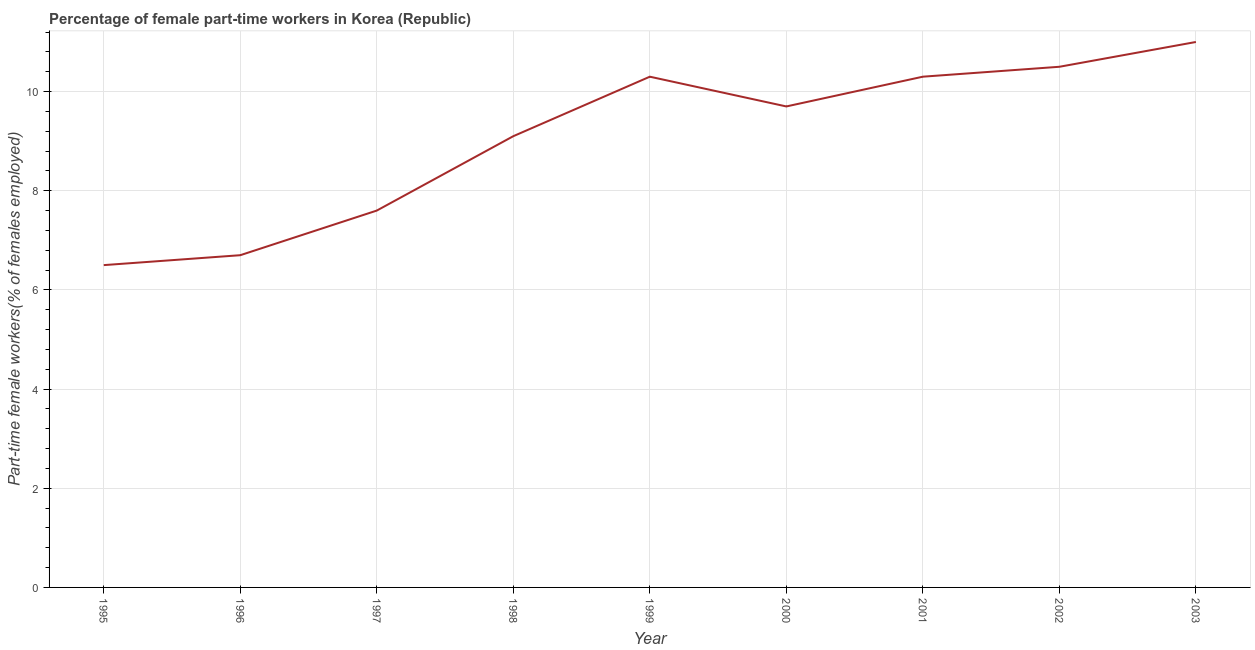What is the percentage of part-time female workers in 2003?
Make the answer very short. 11. In which year was the percentage of part-time female workers maximum?
Give a very brief answer. 2003. In which year was the percentage of part-time female workers minimum?
Keep it short and to the point. 1995. What is the sum of the percentage of part-time female workers?
Provide a succinct answer. 81.7. What is the difference between the percentage of part-time female workers in 1996 and 2001?
Provide a short and direct response. -3.6. What is the average percentage of part-time female workers per year?
Make the answer very short. 9.08. What is the median percentage of part-time female workers?
Your response must be concise. 9.7. Do a majority of the years between 1997 and 2002 (inclusive) have percentage of part-time female workers greater than 6.8 %?
Keep it short and to the point. Yes. What is the ratio of the percentage of part-time female workers in 1996 to that in 1998?
Provide a succinct answer. 0.74. Is the difference between the percentage of part-time female workers in 1998 and 2000 greater than the difference between any two years?
Make the answer very short. No. What is the difference between the highest and the lowest percentage of part-time female workers?
Your answer should be compact. 4.5. How many lines are there?
Provide a succinct answer. 1. What is the difference between two consecutive major ticks on the Y-axis?
Give a very brief answer. 2. What is the title of the graph?
Offer a terse response. Percentage of female part-time workers in Korea (Republic). What is the label or title of the Y-axis?
Offer a terse response. Part-time female workers(% of females employed). What is the Part-time female workers(% of females employed) in 1996?
Make the answer very short. 6.7. What is the Part-time female workers(% of females employed) in 1997?
Ensure brevity in your answer.  7.6. What is the Part-time female workers(% of females employed) of 1998?
Keep it short and to the point. 9.1. What is the Part-time female workers(% of females employed) in 1999?
Offer a very short reply. 10.3. What is the Part-time female workers(% of females employed) in 2000?
Keep it short and to the point. 9.7. What is the Part-time female workers(% of females employed) in 2001?
Give a very brief answer. 10.3. What is the Part-time female workers(% of females employed) of 2002?
Make the answer very short. 10.5. What is the difference between the Part-time female workers(% of females employed) in 1995 and 1997?
Your response must be concise. -1.1. What is the difference between the Part-time female workers(% of females employed) in 1995 and 1999?
Provide a succinct answer. -3.8. What is the difference between the Part-time female workers(% of females employed) in 1995 and 2000?
Provide a succinct answer. -3.2. What is the difference between the Part-time female workers(% of females employed) in 1995 and 2001?
Ensure brevity in your answer.  -3.8. What is the difference between the Part-time female workers(% of females employed) in 1995 and 2002?
Keep it short and to the point. -4. What is the difference between the Part-time female workers(% of females employed) in 1995 and 2003?
Your response must be concise. -4.5. What is the difference between the Part-time female workers(% of females employed) in 1996 and 1999?
Provide a succinct answer. -3.6. What is the difference between the Part-time female workers(% of females employed) in 1997 and 1998?
Your answer should be compact. -1.5. What is the difference between the Part-time female workers(% of females employed) in 1997 and 2000?
Offer a terse response. -2.1. What is the difference between the Part-time female workers(% of females employed) in 1998 and 1999?
Give a very brief answer. -1.2. What is the difference between the Part-time female workers(% of females employed) in 1998 and 2002?
Ensure brevity in your answer.  -1.4. What is the difference between the Part-time female workers(% of females employed) in 1999 and 2000?
Keep it short and to the point. 0.6. What is the difference between the Part-time female workers(% of females employed) in 1999 and 2001?
Ensure brevity in your answer.  0. What is the difference between the Part-time female workers(% of females employed) in 1999 and 2002?
Your response must be concise. -0.2. What is the difference between the Part-time female workers(% of females employed) in 2000 and 2001?
Make the answer very short. -0.6. What is the difference between the Part-time female workers(% of females employed) in 2000 and 2002?
Offer a very short reply. -0.8. What is the difference between the Part-time female workers(% of females employed) in 2001 and 2002?
Ensure brevity in your answer.  -0.2. What is the difference between the Part-time female workers(% of females employed) in 2001 and 2003?
Your answer should be very brief. -0.7. What is the difference between the Part-time female workers(% of females employed) in 2002 and 2003?
Offer a very short reply. -0.5. What is the ratio of the Part-time female workers(% of females employed) in 1995 to that in 1997?
Keep it short and to the point. 0.85. What is the ratio of the Part-time female workers(% of females employed) in 1995 to that in 1998?
Offer a very short reply. 0.71. What is the ratio of the Part-time female workers(% of females employed) in 1995 to that in 1999?
Make the answer very short. 0.63. What is the ratio of the Part-time female workers(% of females employed) in 1995 to that in 2000?
Your response must be concise. 0.67. What is the ratio of the Part-time female workers(% of females employed) in 1995 to that in 2001?
Your answer should be compact. 0.63. What is the ratio of the Part-time female workers(% of females employed) in 1995 to that in 2002?
Provide a succinct answer. 0.62. What is the ratio of the Part-time female workers(% of females employed) in 1995 to that in 2003?
Offer a terse response. 0.59. What is the ratio of the Part-time female workers(% of females employed) in 1996 to that in 1997?
Offer a terse response. 0.88. What is the ratio of the Part-time female workers(% of females employed) in 1996 to that in 1998?
Your answer should be very brief. 0.74. What is the ratio of the Part-time female workers(% of females employed) in 1996 to that in 1999?
Your response must be concise. 0.65. What is the ratio of the Part-time female workers(% of females employed) in 1996 to that in 2000?
Offer a terse response. 0.69. What is the ratio of the Part-time female workers(% of females employed) in 1996 to that in 2001?
Offer a terse response. 0.65. What is the ratio of the Part-time female workers(% of females employed) in 1996 to that in 2002?
Keep it short and to the point. 0.64. What is the ratio of the Part-time female workers(% of females employed) in 1996 to that in 2003?
Ensure brevity in your answer.  0.61. What is the ratio of the Part-time female workers(% of females employed) in 1997 to that in 1998?
Your answer should be compact. 0.83. What is the ratio of the Part-time female workers(% of females employed) in 1997 to that in 1999?
Provide a succinct answer. 0.74. What is the ratio of the Part-time female workers(% of females employed) in 1997 to that in 2000?
Offer a very short reply. 0.78. What is the ratio of the Part-time female workers(% of females employed) in 1997 to that in 2001?
Your answer should be very brief. 0.74. What is the ratio of the Part-time female workers(% of females employed) in 1997 to that in 2002?
Offer a very short reply. 0.72. What is the ratio of the Part-time female workers(% of females employed) in 1997 to that in 2003?
Provide a succinct answer. 0.69. What is the ratio of the Part-time female workers(% of females employed) in 1998 to that in 1999?
Offer a very short reply. 0.88. What is the ratio of the Part-time female workers(% of females employed) in 1998 to that in 2000?
Keep it short and to the point. 0.94. What is the ratio of the Part-time female workers(% of females employed) in 1998 to that in 2001?
Keep it short and to the point. 0.88. What is the ratio of the Part-time female workers(% of females employed) in 1998 to that in 2002?
Make the answer very short. 0.87. What is the ratio of the Part-time female workers(% of females employed) in 1998 to that in 2003?
Provide a short and direct response. 0.83. What is the ratio of the Part-time female workers(% of females employed) in 1999 to that in 2000?
Provide a succinct answer. 1.06. What is the ratio of the Part-time female workers(% of females employed) in 1999 to that in 2001?
Your response must be concise. 1. What is the ratio of the Part-time female workers(% of females employed) in 1999 to that in 2003?
Your answer should be compact. 0.94. What is the ratio of the Part-time female workers(% of females employed) in 2000 to that in 2001?
Offer a very short reply. 0.94. What is the ratio of the Part-time female workers(% of females employed) in 2000 to that in 2002?
Offer a terse response. 0.92. What is the ratio of the Part-time female workers(% of females employed) in 2000 to that in 2003?
Ensure brevity in your answer.  0.88. What is the ratio of the Part-time female workers(% of females employed) in 2001 to that in 2003?
Keep it short and to the point. 0.94. What is the ratio of the Part-time female workers(% of females employed) in 2002 to that in 2003?
Your response must be concise. 0.95. 